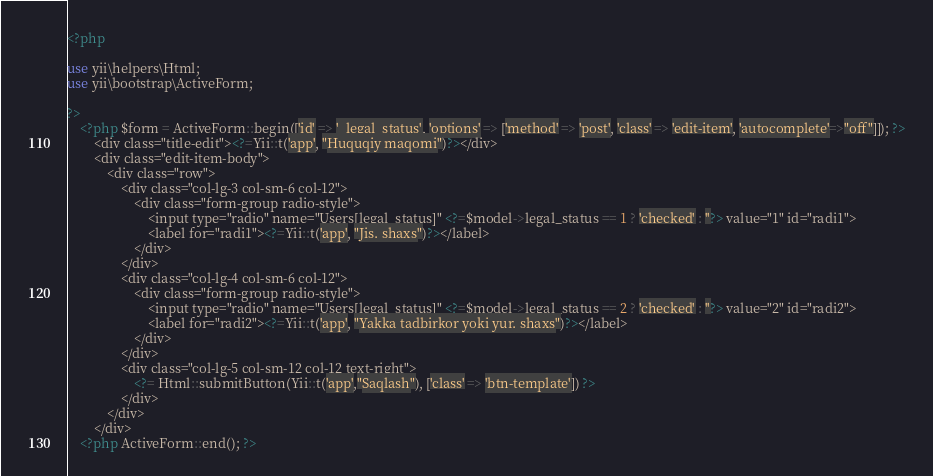<code> <loc_0><loc_0><loc_500><loc_500><_PHP_><?php

use yii\helpers\Html;
use yii\bootstrap\ActiveForm;

?>
    <?php $form = ActiveForm::begin(['id' => '_legal_status', 'options' => ['method' => 'post', 'class' => 'edit-item', 'autocomplete'=>"off"]]); ?>
        <div class="title-edit"><?=Yii::t('app', "Huquqiy maqomi")?></div>
        <div class="edit-item-body">
            <div class="row">
                <div class="col-lg-3 col-sm-6 col-12">
                    <div class="form-group radio-style">
                        <input type="radio" name="Users[legal_status]" <?=$model->legal_status == 1 ? 'checked' : ''?> value="1" id="radi1">
                        <label for="radi1"><?=Yii::t('app', "Jis. shaxs")?></label>
                    </div>
                </div>
                <div class="col-lg-4 col-sm-6 col-12">
                    <div class="form-group radio-style">
                        <input type="radio" name="Users[legal_status]" <?=$model->legal_status == 2 ? 'checked' : ''?> value="2" id="radi2">
                        <label for="radi2"><?=Yii::t('app', "Yakka tadbirkor yoki yur. shaxs")?></label>
                    </div>
                </div>
                <div class="col-lg-5 col-sm-12 col-12 text-right">
                    <?= Html::submitButton(Yii::t('app',"Saqlash"), ['class' => 'btn-template']) ?>
                </div>
            </div>
        </div>
    <?php ActiveForm::end(); ?></code> 